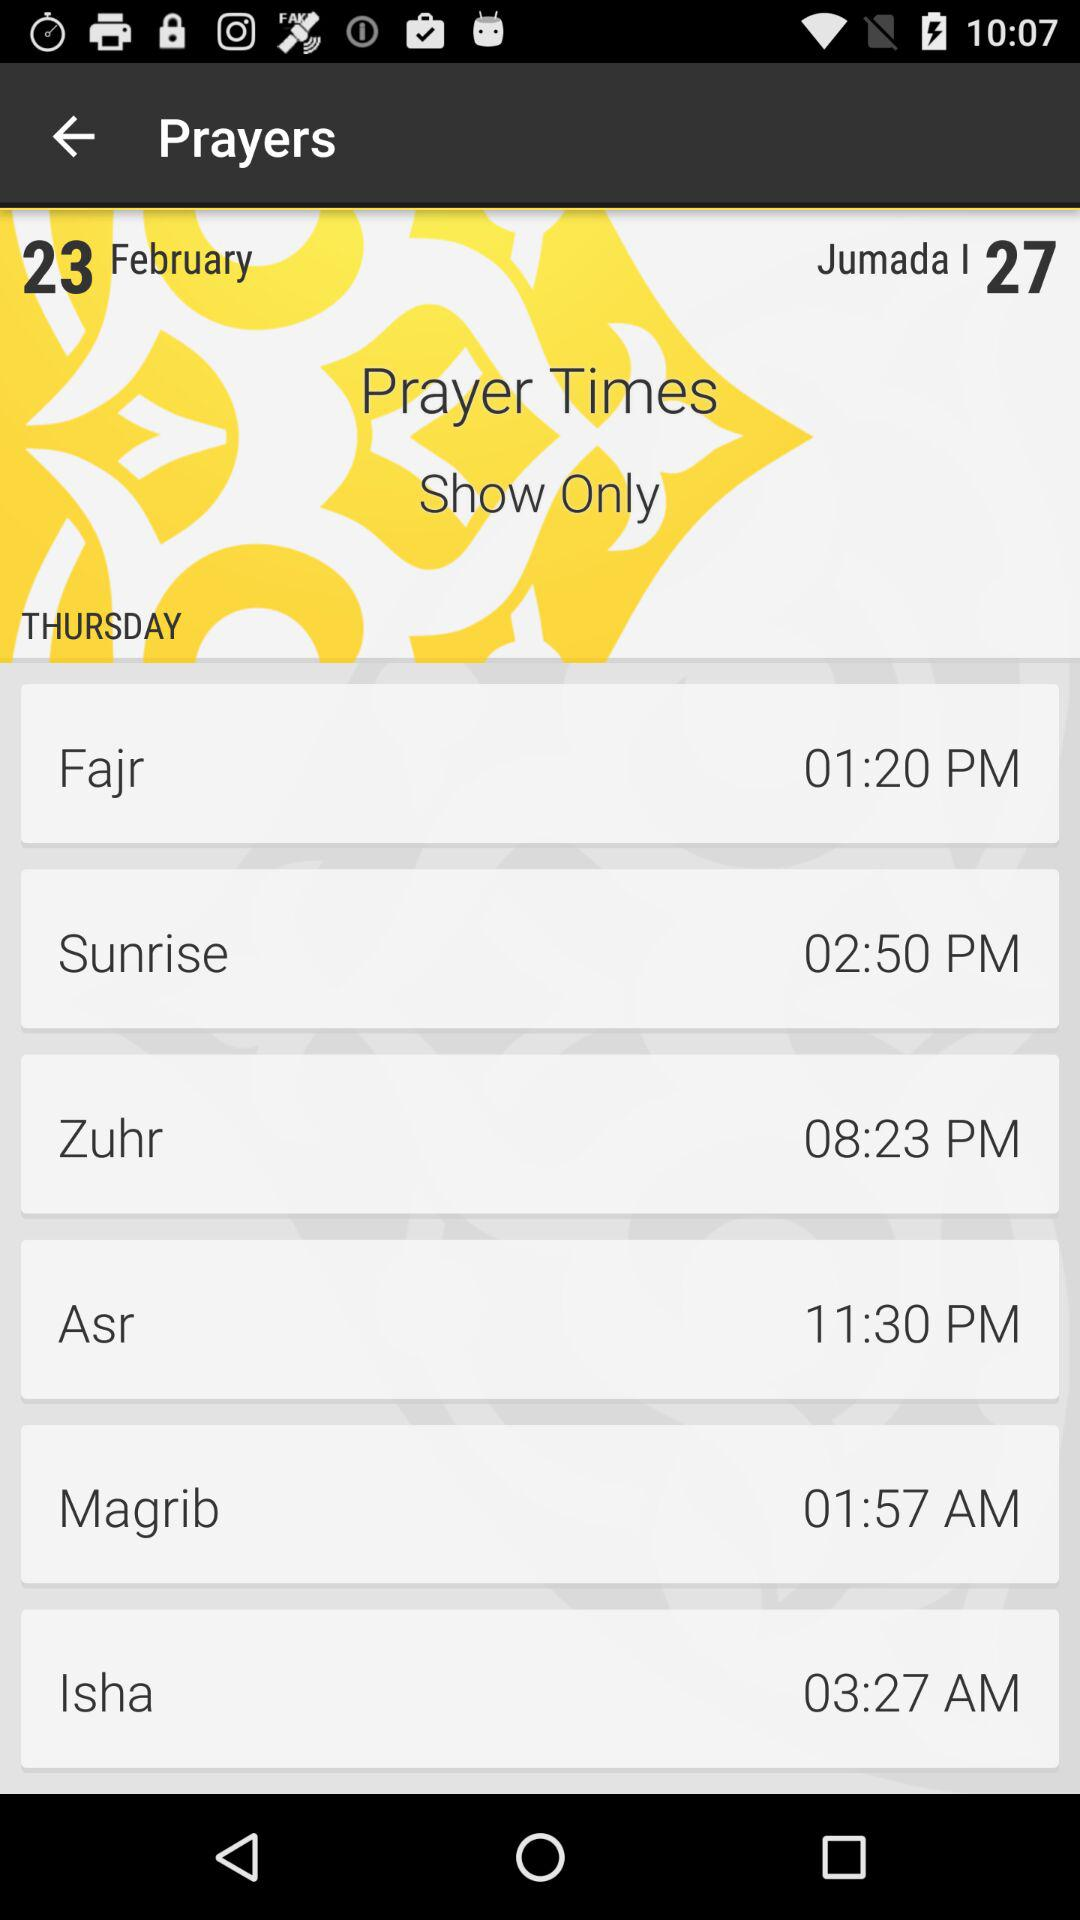What date is shown on the screen? The date shown on the screen is Thursday, February 23. 